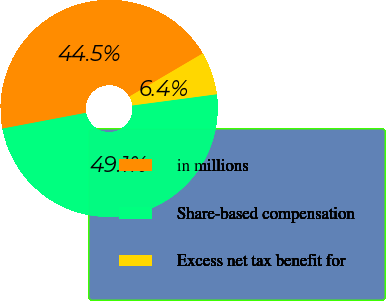Convert chart to OTSL. <chart><loc_0><loc_0><loc_500><loc_500><pie_chart><fcel>in millions<fcel>Share-based compensation<fcel>Excess net tax benefit for<nl><fcel>44.51%<fcel>49.13%<fcel>6.36%<nl></chart> 